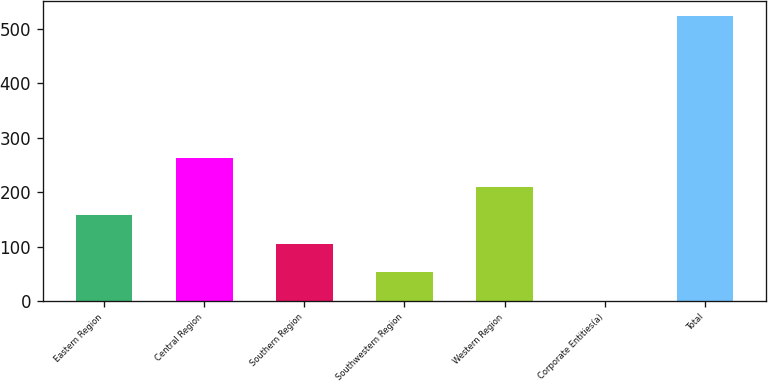Convert chart. <chart><loc_0><loc_0><loc_500><loc_500><bar_chart><fcel>Eastern Region<fcel>Central Region<fcel>Southern Region<fcel>Southwestern Region<fcel>Western Region<fcel>Corporate Entities(a)<fcel>Total<nl><fcel>157.39<fcel>262.25<fcel>104.96<fcel>52.53<fcel>209.82<fcel>0.1<fcel>524.4<nl></chart> 